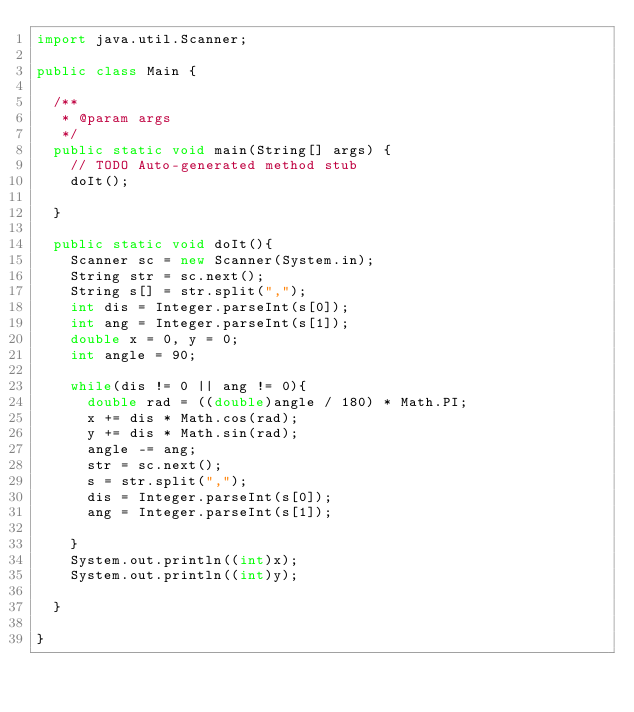Convert code to text. <code><loc_0><loc_0><loc_500><loc_500><_Java_>import java.util.Scanner;

public class Main {

	/**
	 * @param args
	 */
	public static void main(String[] args) {
		// TODO Auto-generated method stub
		doIt();

	}
	
	public static void doIt(){
		Scanner sc = new Scanner(System.in);
		String str = sc.next();
		String s[] = str.split(",");
		int dis = Integer.parseInt(s[0]);
		int ang = Integer.parseInt(s[1]);
		double x = 0, y = 0;
		int angle = 90;

		while(dis != 0 || ang != 0){
			double rad = ((double)angle / 180) * Math.PI;
			x += dis * Math.cos(rad);
			y += dis * Math.sin(rad);
			angle -= ang;
			str = sc.next();
			s = str.split(",");
			dis = Integer.parseInt(s[0]);
			ang = Integer.parseInt(s[1]);
			
		}
		System.out.println((int)x);
		System.out.println((int)y);
		
	}

}</code> 